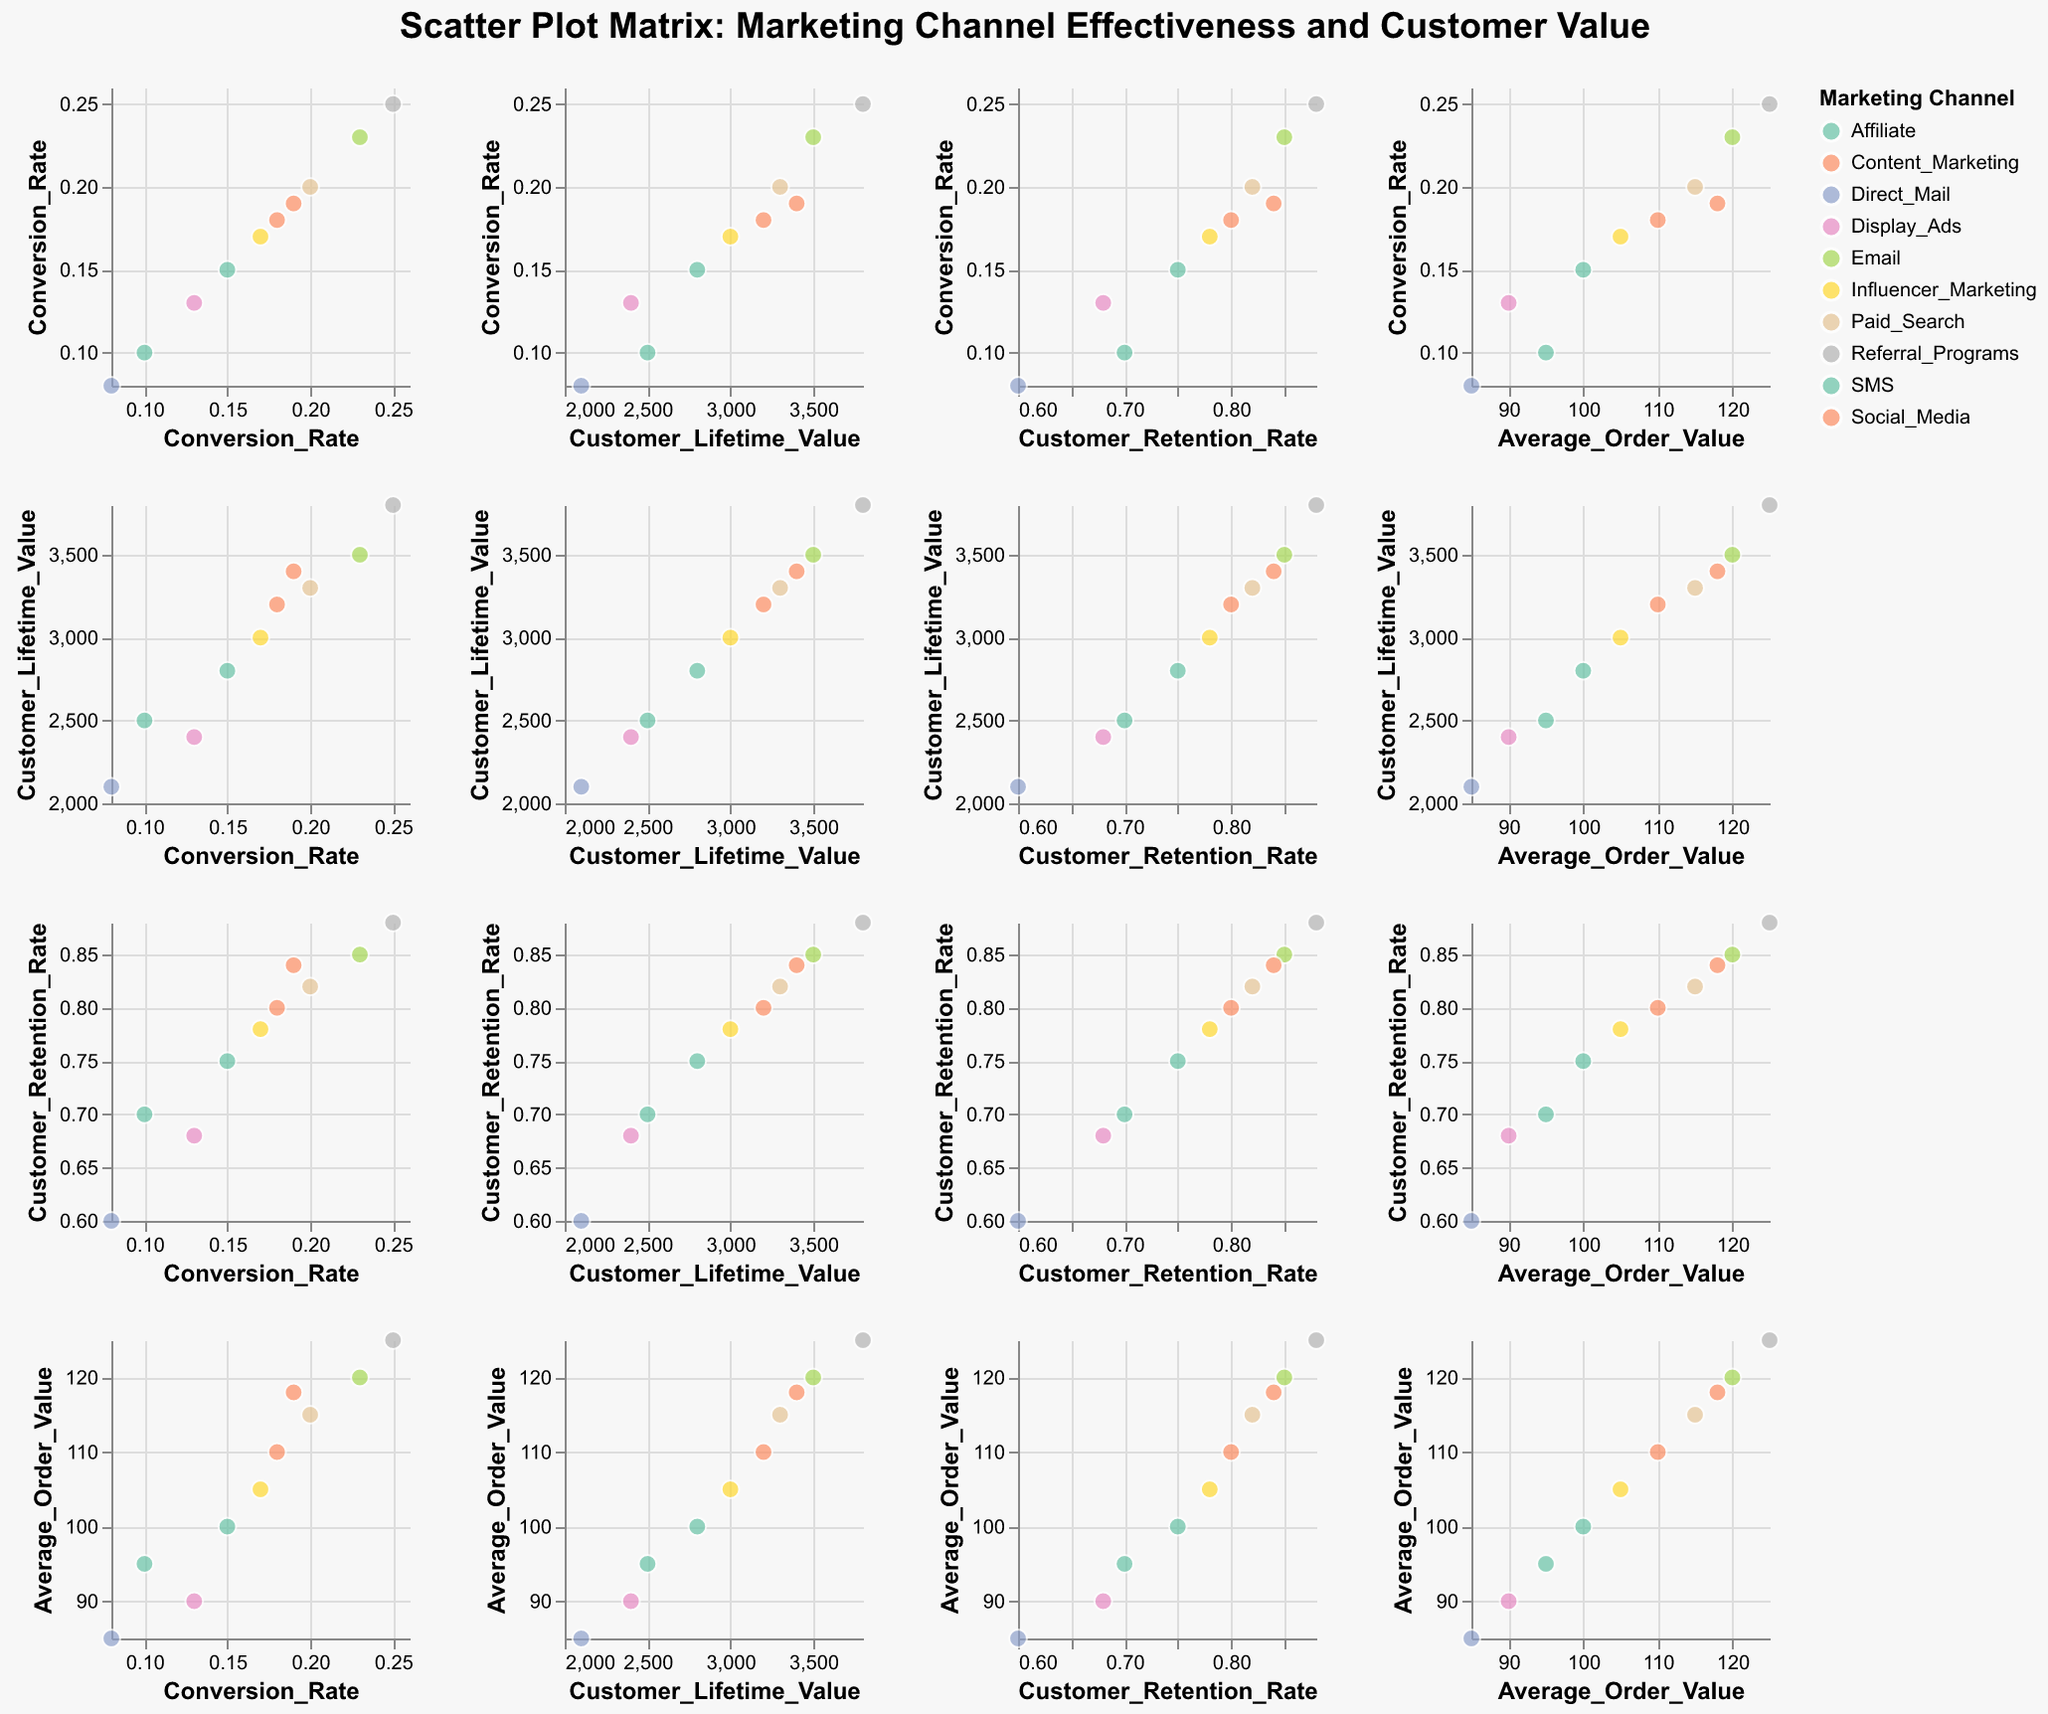What is the title of the scatter plot matrix? The title is usually found at the top center of the figure. In this case, it reads: "Scatter Plot Matrix: Marketing Channel Effectiveness and Customer Value".
Answer: Scatter Plot Matrix: Marketing Channel Effectiveness and Customer Value How many marketing channels are represented in the figure? By examining the legend or noting the distinct colors, we see there are 10 different marketing channels represented in the plot.
Answer: 10 Which marketing channel has the highest Customer Lifetime Value (CLV)? Locate the highest point on the Customer Lifetime Value axis, and check the corresponding Marketing Channel in the scatter plots. Referral Programs has the highest CLV at 3800.
Answer: Referral Programs Is there a positive correlation between Conversion Rate and Customer Lifetime Value? By observing the scatter plot between Conversion Rate (x-axis) and Customer Lifetime Value (y-axis), we can see that higher conversion rates generally correspond with higher CLV, indicating a positive correlation.
Answer: Yes Among Email, SMS, and Social Media, which channel has the highest Average Order Value? Compare the points for Email, SMS, and Social Media on the scatter plot matrix where the y-axis is Average Order Value. Email's Average Order Value is 120, which is higher than SMS's 100 and Social Media's 110.
Answer: Email Which marketing channel has the lowest Customer Retention Rate? Locate the lowest point on the Customer Retention Rate axis in the scatter plots, and identify the corresponding Marketing Channel. Direct Mail has the lowest retention rate at 0.60.
Answer: Direct Mail Does Influencer Marketing have a higher or lower Customer Retention Rate compared to Content Marketing? In the scatter plot matrix where the y-axis shows Customer Retention Rate, locate the points for Influencer Marketing and Content Marketing. Influencer Marketing has a retention rate of 0.78, while Content Marketing has 0.84, so it is lower.
Answer: Lower Which metric appears to have the widest range across channels, Conversion Rate or Customer Lifetime Value? By comparing the range of values on the axes for Conversion Rate and Customer Lifetime Value, we note that Customer Lifetime Value ranges from 2100 to 3800 (a range of 1700), while Conversion Rate ranges from 0.08 to 0.25 (a range of 0.17). Customer Lifetime Value has a wider range.
Answer: Customer Lifetime Value How does the Conversion Rate of Affiliate marketing compare with that of Paid Search? Locate the scatter plots where Conversion Rate is on the x-axis and identify the points for Affiliate (Conversion Rate of 0.10) and Paid Search (0.20). Paid Search has a higher conversion rate.
Answer: Paid Search Considering Customer Retention Rate and Average Order Value, which marketing channel exhibits both high retention and high order value? Locate the points in the scatter plots where Customer Retention Rate and Average Order Value intersect, Search for points that are high on both axes. Email and Referral Programs stand out with high values in both metrics, but Referral Programs has the higher values.
Answer: Referral Programs 